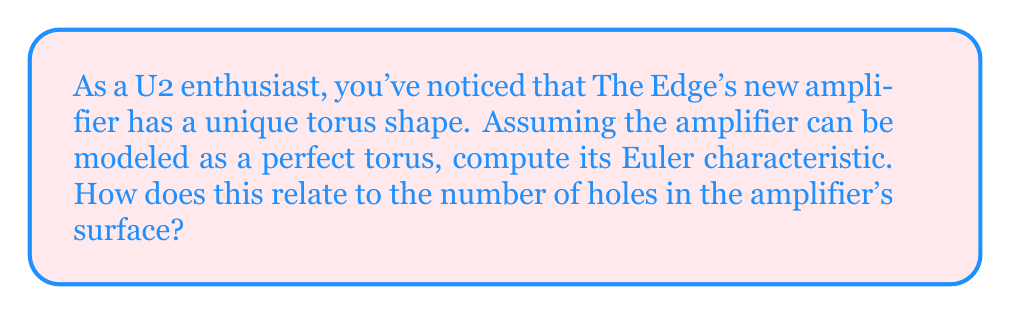Give your solution to this math problem. To compute the Euler characteristic of a torus-shaped amplifier, we need to understand the topological properties of a torus and apply the Euler-Poincaré formula.

1. The Euler-Poincaré formula:
   The Euler characteristic $\chi$ is given by:
   $$\chi = V - E + F$$
   where $V$ is the number of vertices, $E$ is the number of edges, and $F$ is the number of faces in a polygonal decomposition of the surface.

2. Torus properties:
   A torus is a surface of genus 1, meaning it has one hole. It can be represented as a rectangle with opposite edges identified.

3. Minimal polygonal decomposition of a torus:
   The simplest decomposition consists of:
   - 1 vertex (all corners of the rectangle are identified)
   - 2 edges (one pair of opposite edges becomes a meridian, the other a longitude)
   - 1 face (the interior of the rectangle)

4. Calculation:
   $$\chi = V - E + F = 1 - 2 + 1 = 0$$

5. Relationship to genus:
   For a closed orientable surface, the Euler characteristic is related to the genus $g$ by:
   $$\chi = 2 - 2g$$

   Solving for $g$:
   $$g = \frac{2 - \chi}{2} = \frac{2 - 0}{2} = 1$$

This confirms that the torus has genus 1, corresponding to one hole in its surface.
Answer: The Euler characteristic of a torus-shaped amplifier is $\chi = 0$. This corresponds to a surface with one hole (genus 1), which is consistent with the topology of a torus. 